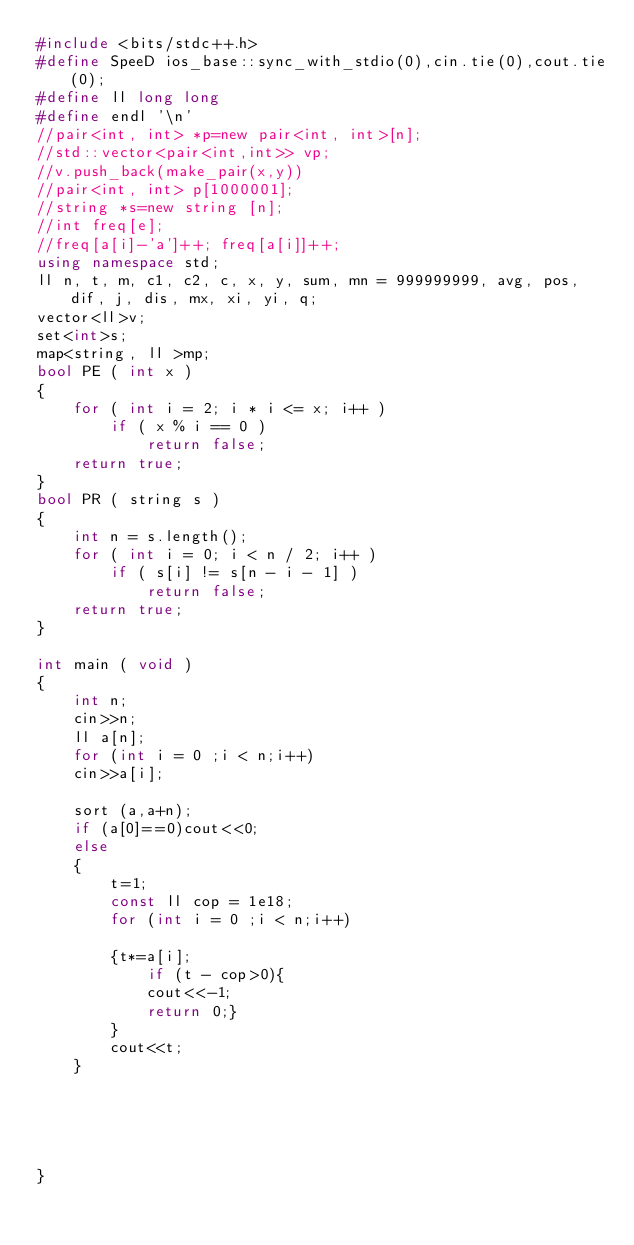<code> <loc_0><loc_0><loc_500><loc_500><_C++_>#include <bits/stdc++.h>
#define SpeeD ios_base::sync_with_stdio(0),cin.tie(0),cout.tie(0);
#define ll long long
#define endl '\n'
//pair<int, int> *p=new pair<int, int>[n];
//std::vector<pair<int,int>> vp;
//v.push_back(make_pair(x,y))
//pair<int, int> p[1000001];
//string *s=new string [n];
//int freq[e];
//freq[a[i]-'a']++; freq[a[i]]++;
using namespace std;
ll n, t, m, c1, c2, c, x, y, sum, mn = 999999999, avg, pos, dif, j, dis, mx, xi, yi, q;
vector<ll>v;
set<int>s;
map<string, ll >mp;
bool PE ( int x )
{
    for ( int i = 2; i * i <= x; i++ )
        if ( x % i == 0 )
            return false;
    return true;
}
bool PR ( string s )
{
    int n = s.length();
    for ( int i = 0; i < n / 2; i++ )
        if ( s[i] != s[n - i - 1] )
            return false;
    return true;
}

int main ( void )
{ 
    int n;
    cin>>n;
    ll a[n];
    for (int i = 0 ;i < n;i++)
    cin>>a[i];
    
    sort (a,a+n);
    if (a[0]==0)cout<<0;
    else
    {
        t=1;
        const ll cop = 1e18;
        for (int i = 0 ;i < n;i++)
        
        {t*=a[i];
            if (t - cop>0){
            cout<<-1;
            return 0;}
        }
        cout<<t;
    }
    
     
     
    
   
}
</code> 